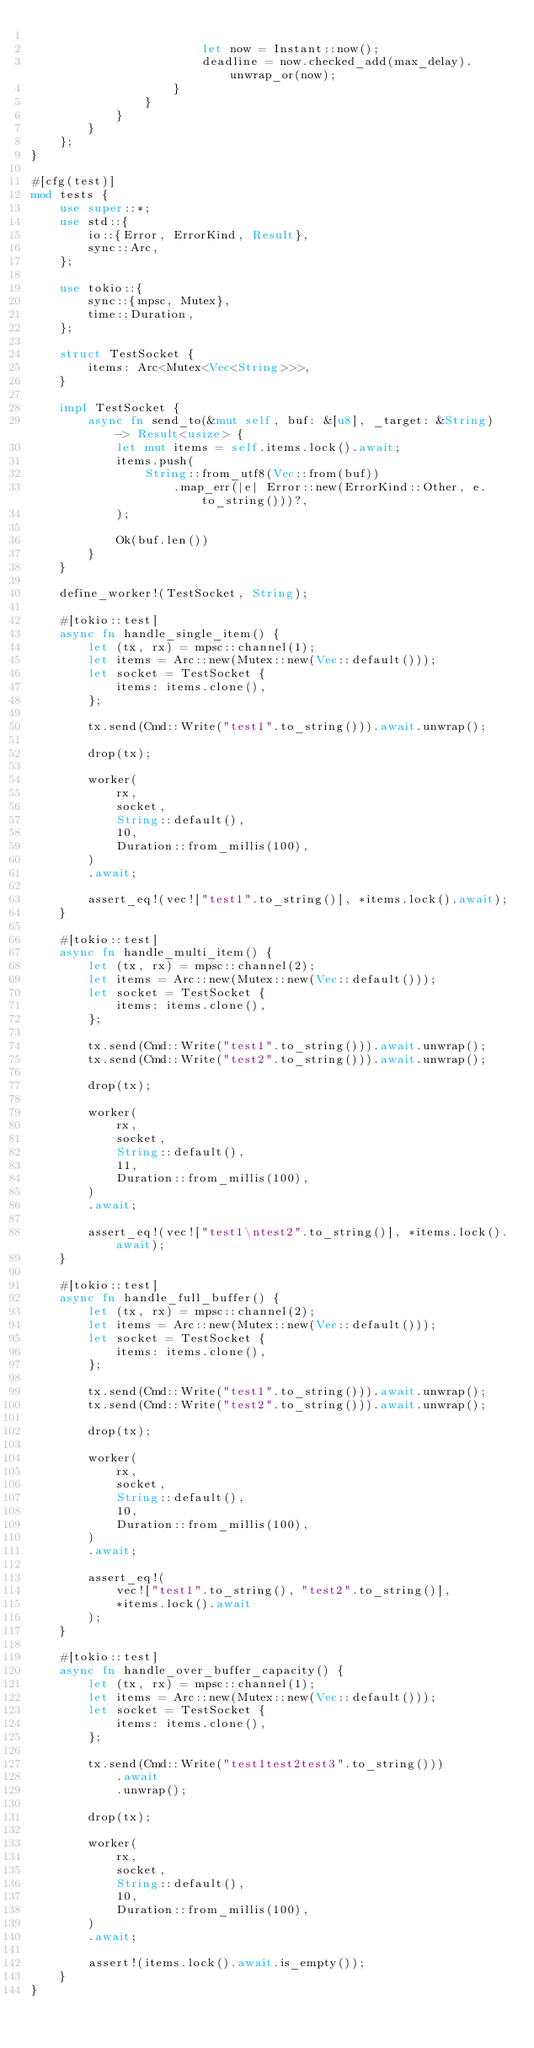<code> <loc_0><loc_0><loc_500><loc_500><_Rust_>
                        let now = Instant::now();
                        deadline = now.checked_add(max_delay).unwrap_or(now);
                    }
                }
            }
        }
    };
}

#[cfg(test)]
mod tests {
    use super::*;
    use std::{
        io::{Error, ErrorKind, Result},
        sync::Arc,
    };

    use tokio::{
        sync::{mpsc, Mutex},
        time::Duration,
    };

    struct TestSocket {
        items: Arc<Mutex<Vec<String>>>,
    }

    impl TestSocket {
        async fn send_to(&mut self, buf: &[u8], _target: &String) -> Result<usize> {
            let mut items = self.items.lock().await;
            items.push(
                String::from_utf8(Vec::from(buf))
                    .map_err(|e| Error::new(ErrorKind::Other, e.to_string()))?,
            );

            Ok(buf.len())
        }
    }

    define_worker!(TestSocket, String);

    #[tokio::test]
    async fn handle_single_item() {
        let (tx, rx) = mpsc::channel(1);
        let items = Arc::new(Mutex::new(Vec::default()));
        let socket = TestSocket {
            items: items.clone(),
        };

        tx.send(Cmd::Write("test1".to_string())).await.unwrap();

        drop(tx);

        worker(
            rx,
            socket,
            String::default(),
            10,
            Duration::from_millis(100),
        )
        .await;

        assert_eq!(vec!["test1".to_string()], *items.lock().await);
    }

    #[tokio::test]
    async fn handle_multi_item() {
        let (tx, rx) = mpsc::channel(2);
        let items = Arc::new(Mutex::new(Vec::default()));
        let socket = TestSocket {
            items: items.clone(),
        };

        tx.send(Cmd::Write("test1".to_string())).await.unwrap();
        tx.send(Cmd::Write("test2".to_string())).await.unwrap();

        drop(tx);

        worker(
            rx,
            socket,
            String::default(),
            11,
            Duration::from_millis(100),
        )
        .await;

        assert_eq!(vec!["test1\ntest2".to_string()], *items.lock().await);
    }

    #[tokio::test]
    async fn handle_full_buffer() {
        let (tx, rx) = mpsc::channel(2);
        let items = Arc::new(Mutex::new(Vec::default()));
        let socket = TestSocket {
            items: items.clone(),
        };

        tx.send(Cmd::Write("test1".to_string())).await.unwrap();
        tx.send(Cmd::Write("test2".to_string())).await.unwrap();

        drop(tx);

        worker(
            rx,
            socket,
            String::default(),
            10,
            Duration::from_millis(100),
        )
        .await;

        assert_eq!(
            vec!["test1".to_string(), "test2".to_string()],
            *items.lock().await
        );
    }

    #[tokio::test]
    async fn handle_over_buffer_capacity() {
        let (tx, rx) = mpsc::channel(1);
        let items = Arc::new(Mutex::new(Vec::default()));
        let socket = TestSocket {
            items: items.clone(),
        };

        tx.send(Cmd::Write("test1test2test3".to_string()))
            .await
            .unwrap();

        drop(tx);

        worker(
            rx,
            socket,
            String::default(),
            10,
            Duration::from_millis(100),
        )
        .await;

        assert!(items.lock().await.is_empty());
    }
}
</code> 